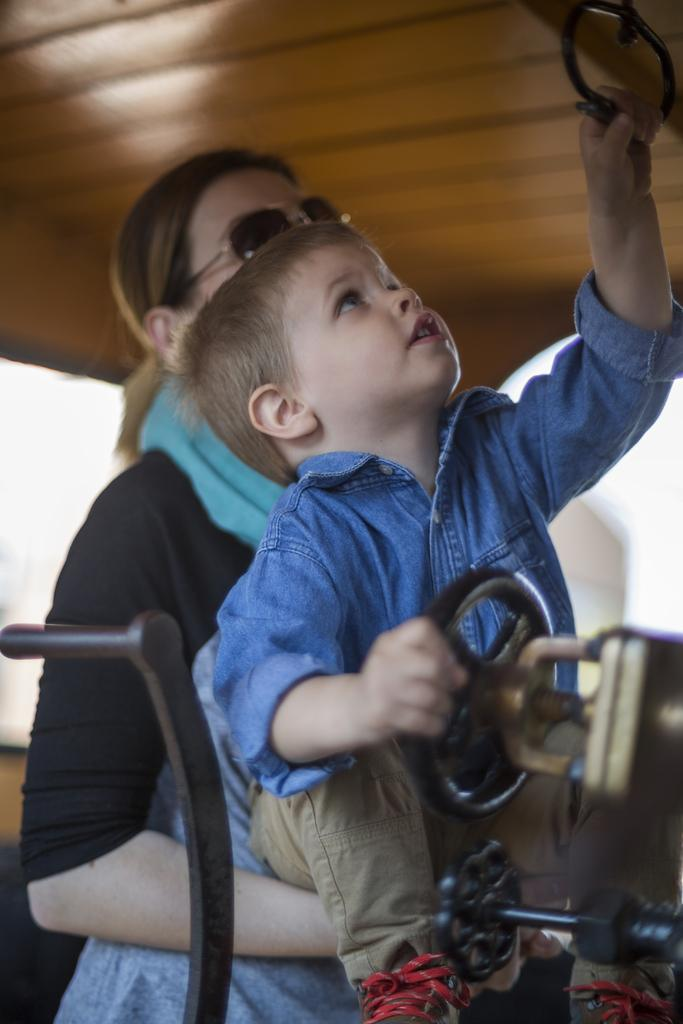Who is present in the image? There is a woman and a kid in the image. What is the kid holding in the image? The kid is holding an object in the image. What accessories is the woman wearing in the image? The woman is wearing a scarf and goggles in the image. What type of grain can be seen in the woman's hair in the image? There is no grain visible in the woman's hair in the image. 